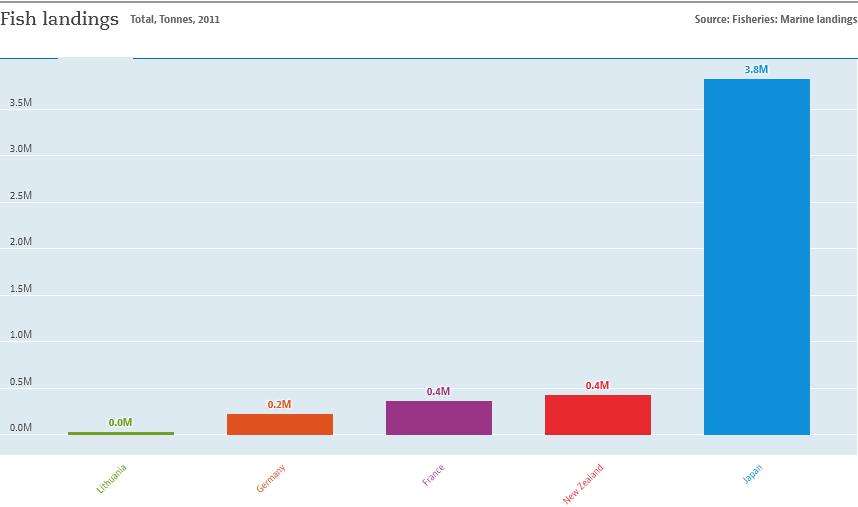List a handful of essential elements in this visual. The Bar chart displays values with a minimum of 0.0M. Yes, the lowest value in the Bar chart is 0.0M. The ratio of the largest bar to the second lowest bar is 19 to 1. 